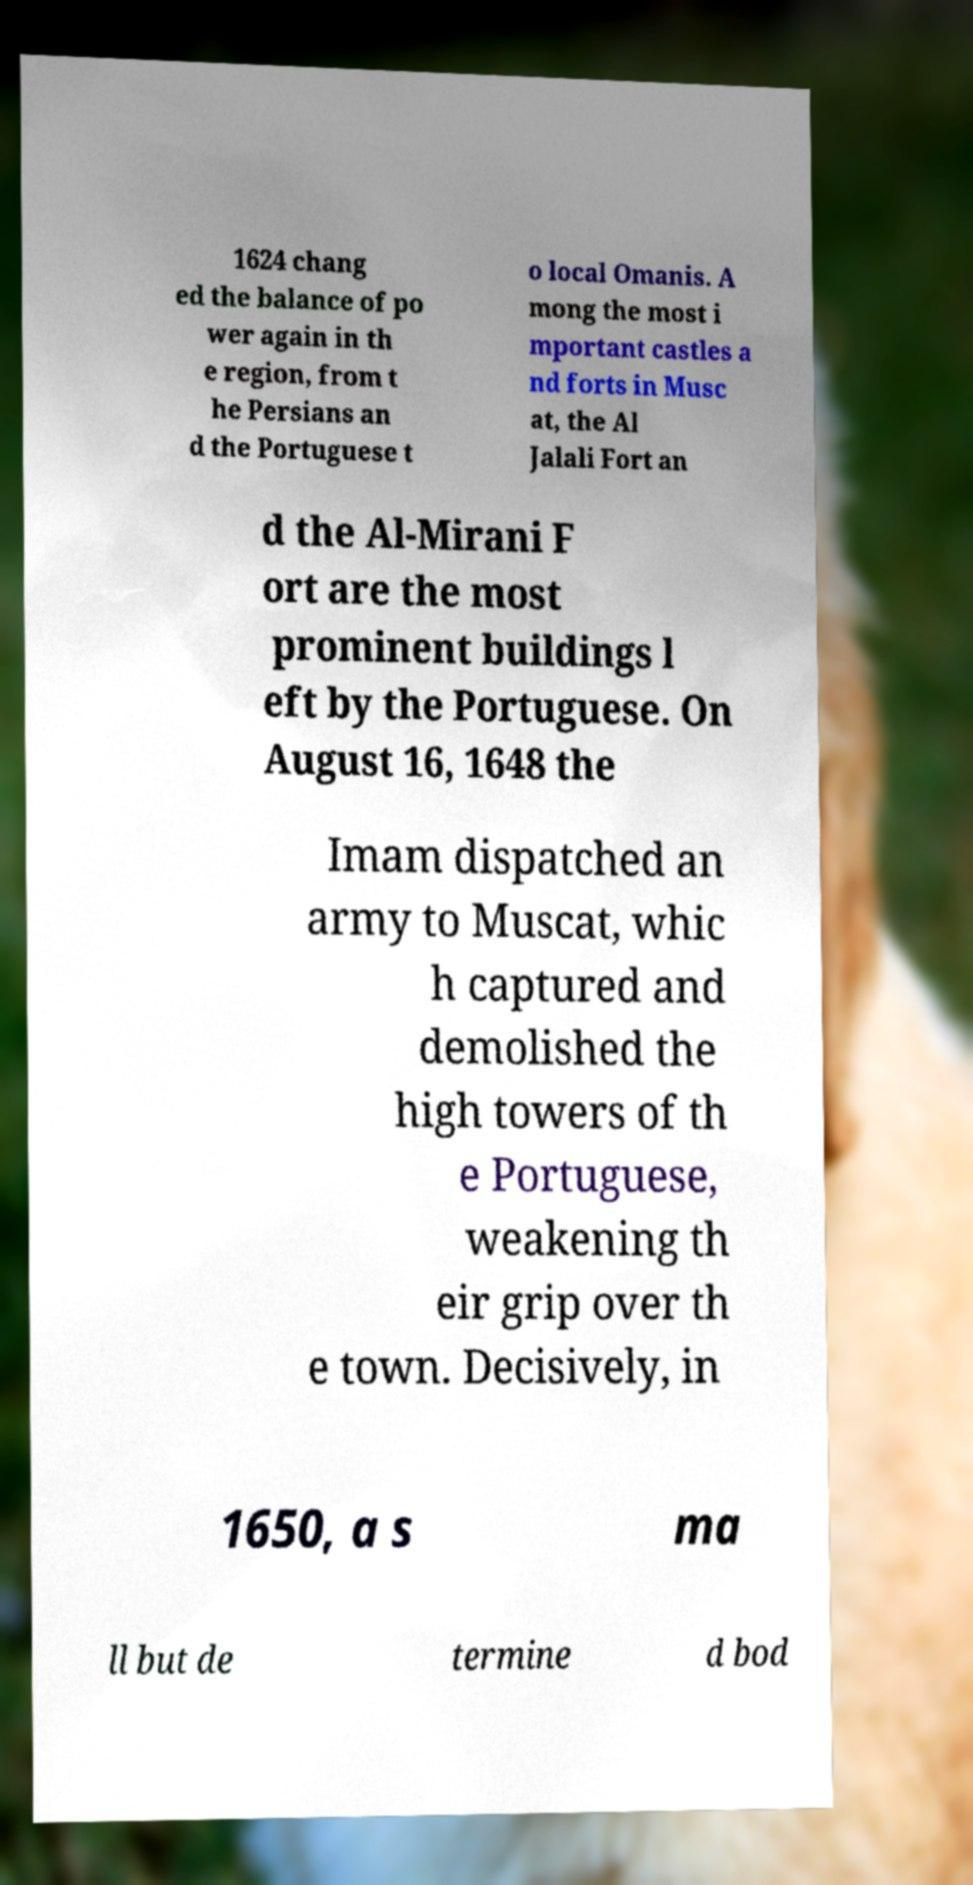Can you read and provide the text displayed in the image?This photo seems to have some interesting text. Can you extract and type it out for me? 1624 chang ed the balance of po wer again in th e region, from t he Persians an d the Portuguese t o local Omanis. A mong the most i mportant castles a nd forts in Musc at, the Al Jalali Fort an d the Al-Mirani F ort are the most prominent buildings l eft by the Portuguese. On August 16, 1648 the Imam dispatched an army to Muscat, whic h captured and demolished the high towers of th e Portuguese, weakening th eir grip over th e town. Decisively, in 1650, a s ma ll but de termine d bod 